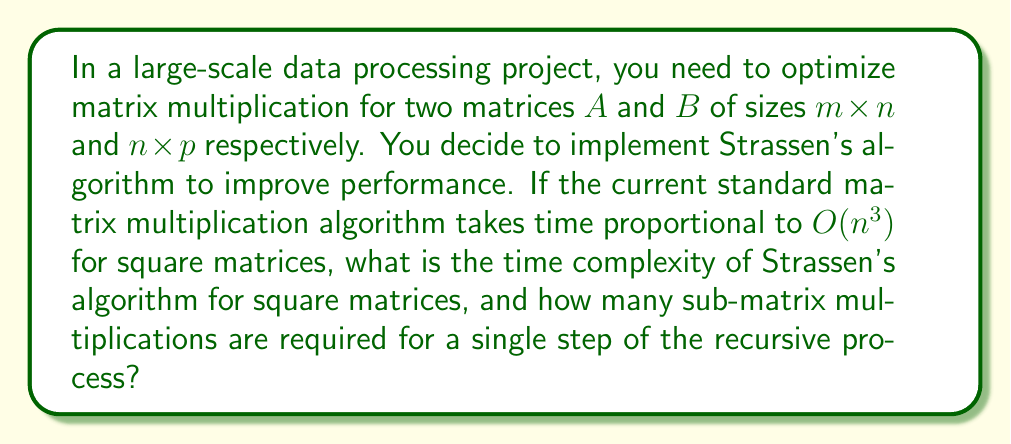Teach me how to tackle this problem. To answer this question, let's break it down step by step:

1) Standard matrix multiplication:
   The standard algorithm for multiplying two $n \times n$ matrices requires $n^3$ multiplications, hence its time complexity is $O(n^3)$.

2) Strassen's algorithm:
   Strassen's algorithm is a divide-and-conquer method that reduces the number of recursive multiplications needed for matrix multiplication.

3) Process of Strassen's algorithm:
   a) Divide each matrix into four sub-matrices of size $\frac{n}{2} \times \frac{n}{2}$.
   b) Perform 7 multiplications of these sub-matrices (instead of 8 in the standard method).
   c) Use these results to compute the four quadrants of the result matrix.

4) Recursive nature:
   This process is applied recursively to the sub-matrices until we reach a base case (usually 1x1 matrices).

5) Time complexity analysis:
   Let $T(n)$ be the time complexity for $n \times n$ matrices.
   $$T(n) = 7T(\frac{n}{2}) + O(n^2)$$
   The $O(n^2)$ term accounts for the additions and subtractions of sub-matrices.

6) Solving the recurrence relation:
   Using the Master Theorem, we can solve this recurrence:
   $$T(n) = \Theta(n^{\log_2 7}) \approx O(n^{2.8074})$$

7) Number of sub-matrix multiplications:
   In each recursive step, Strassen's algorithm performs 7 sub-matrix multiplications.

As a software engineer familiar with AutoIt, you could implement this algorithm using recursive functions or iterative methods with matrix partitioning, potentially utilizing AutoIt's array handling capabilities for efficient matrix operations.
Answer: The time complexity of Strassen's algorithm for square matrices is $O(n^{\log_2 7}) \approx O(n^{2.8074})$, and it requires 7 sub-matrix multiplications for a single step of the recursive process. 